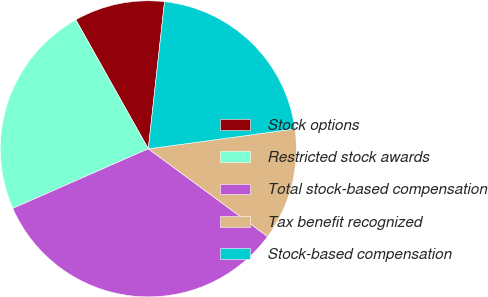Convert chart. <chart><loc_0><loc_0><loc_500><loc_500><pie_chart><fcel>Stock options<fcel>Restricted stock awards<fcel>Total stock-based compensation<fcel>Tax benefit recognized<fcel>Stock-based compensation<nl><fcel>9.89%<fcel>23.45%<fcel>33.31%<fcel>12.23%<fcel>21.11%<nl></chart> 